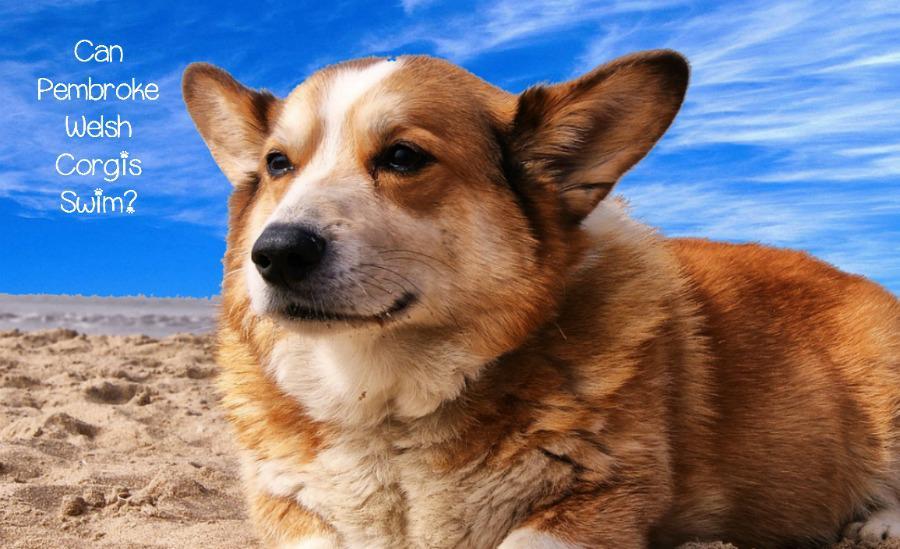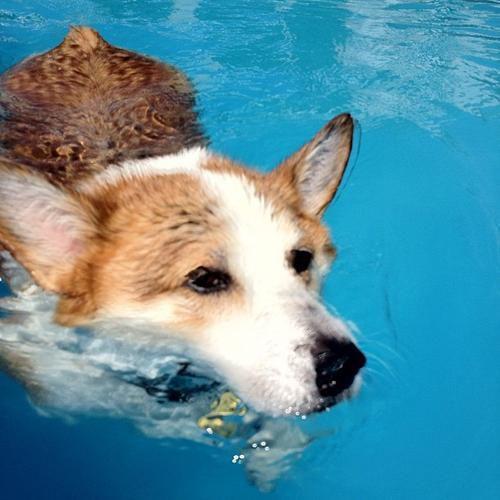The first image is the image on the left, the second image is the image on the right. For the images displayed, is the sentence "there is at least one corgi in a pool on an inflatable mat wearing sunglasses with it's tongue sticking out" factually correct? Answer yes or no. No. 